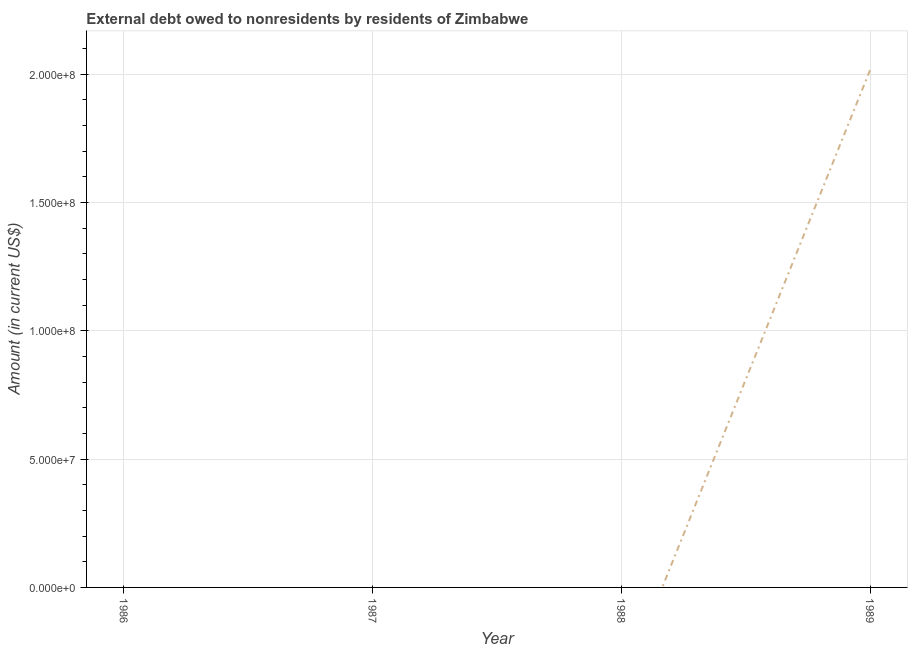Across all years, what is the maximum debt?
Make the answer very short. 2.02e+08. Across all years, what is the minimum debt?
Give a very brief answer. 0. In which year was the debt maximum?
Offer a terse response. 1989. What is the sum of the debt?
Make the answer very short. 2.02e+08. What is the average debt per year?
Provide a succinct answer. 5.04e+07. What is the median debt?
Your answer should be very brief. 0. In how many years, is the debt greater than 180000000 US$?
Offer a very short reply. 1. What is the difference between the highest and the lowest debt?
Provide a succinct answer. 2.02e+08. Does the debt monotonically increase over the years?
Provide a short and direct response. Yes. How many lines are there?
Offer a terse response. 1. How many years are there in the graph?
Your answer should be compact. 4. What is the difference between two consecutive major ticks on the Y-axis?
Keep it short and to the point. 5.00e+07. Does the graph contain any zero values?
Offer a very short reply. Yes. Does the graph contain grids?
Offer a terse response. Yes. What is the title of the graph?
Your response must be concise. External debt owed to nonresidents by residents of Zimbabwe. What is the label or title of the Y-axis?
Offer a very short reply. Amount (in current US$). What is the Amount (in current US$) of 1986?
Provide a succinct answer. 0. What is the Amount (in current US$) of 1987?
Ensure brevity in your answer.  0. What is the Amount (in current US$) in 1988?
Offer a terse response. 0. What is the Amount (in current US$) in 1989?
Offer a very short reply. 2.02e+08. 